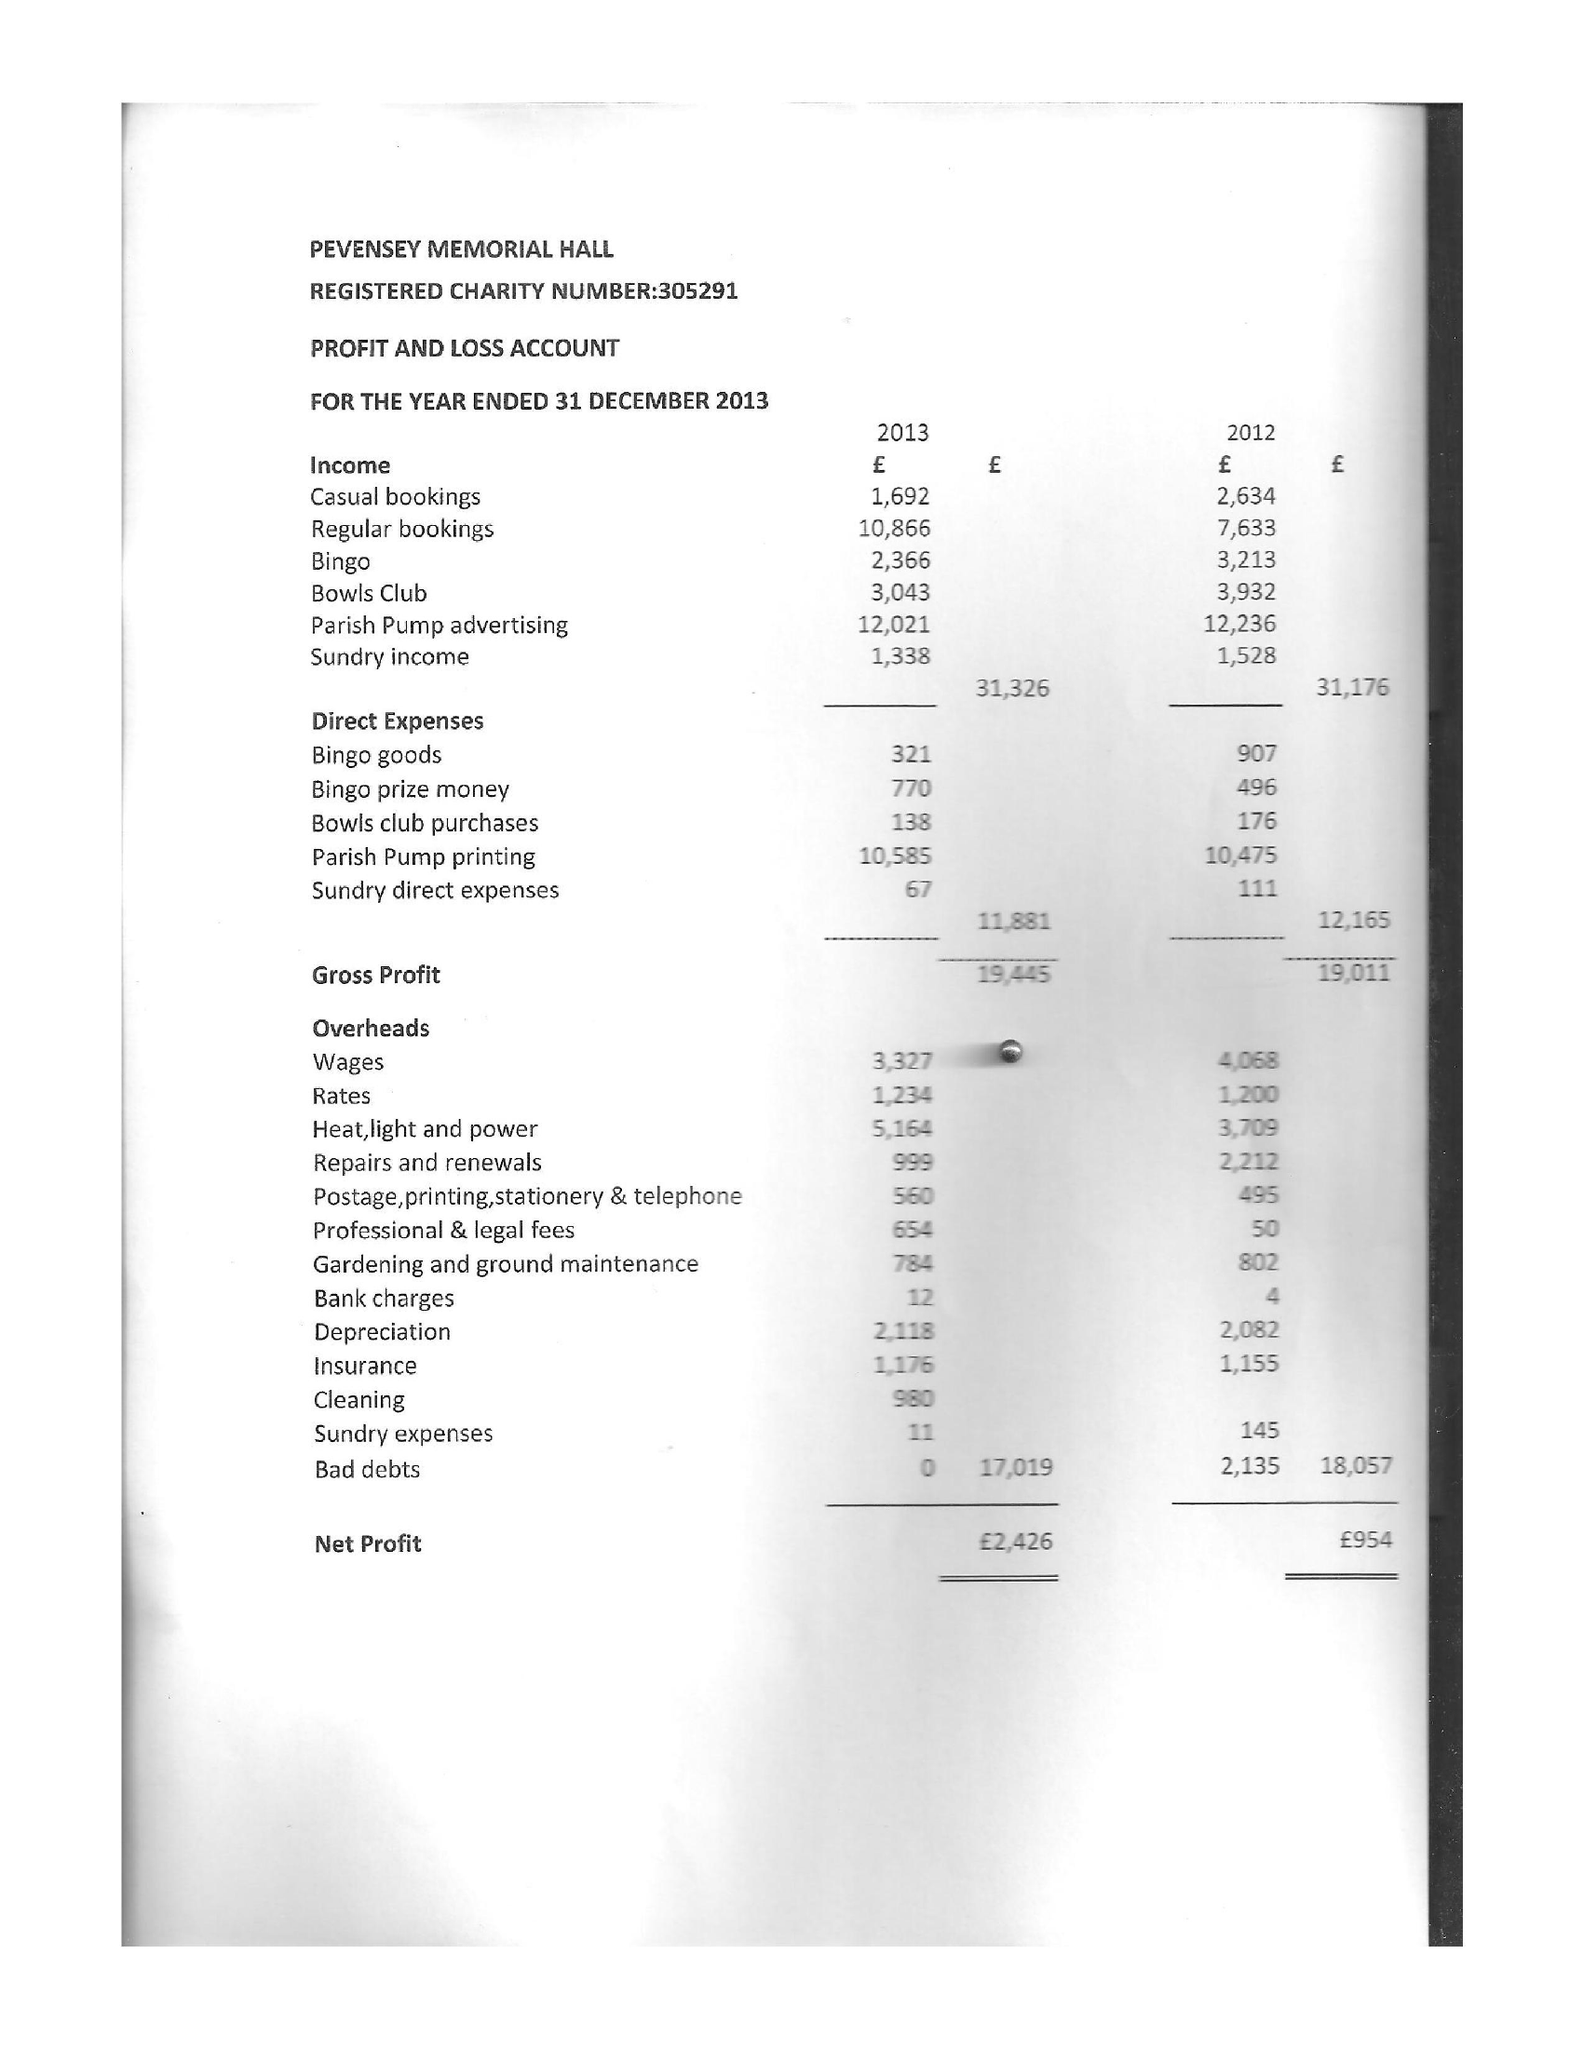What is the value for the charity_name?
Answer the question using a single word or phrase. Pevensey Memorial Hall 